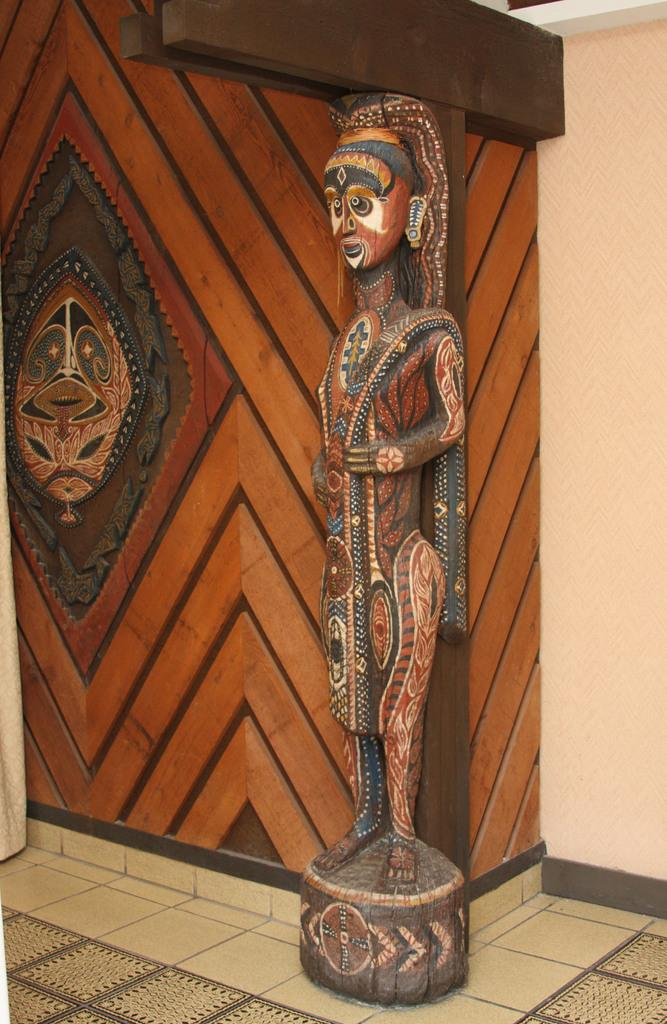What is the main subject in the image? There is a statue in the image. What else can be seen in the image besides the statue? There is a wall with a design in the image. How many icicles are hanging from the statue in the image? There are no icicles present in the image. What type of furniture can be seen near the statue in the image? There is no furniture present in the image; it only features a statue and a wall with a design. 